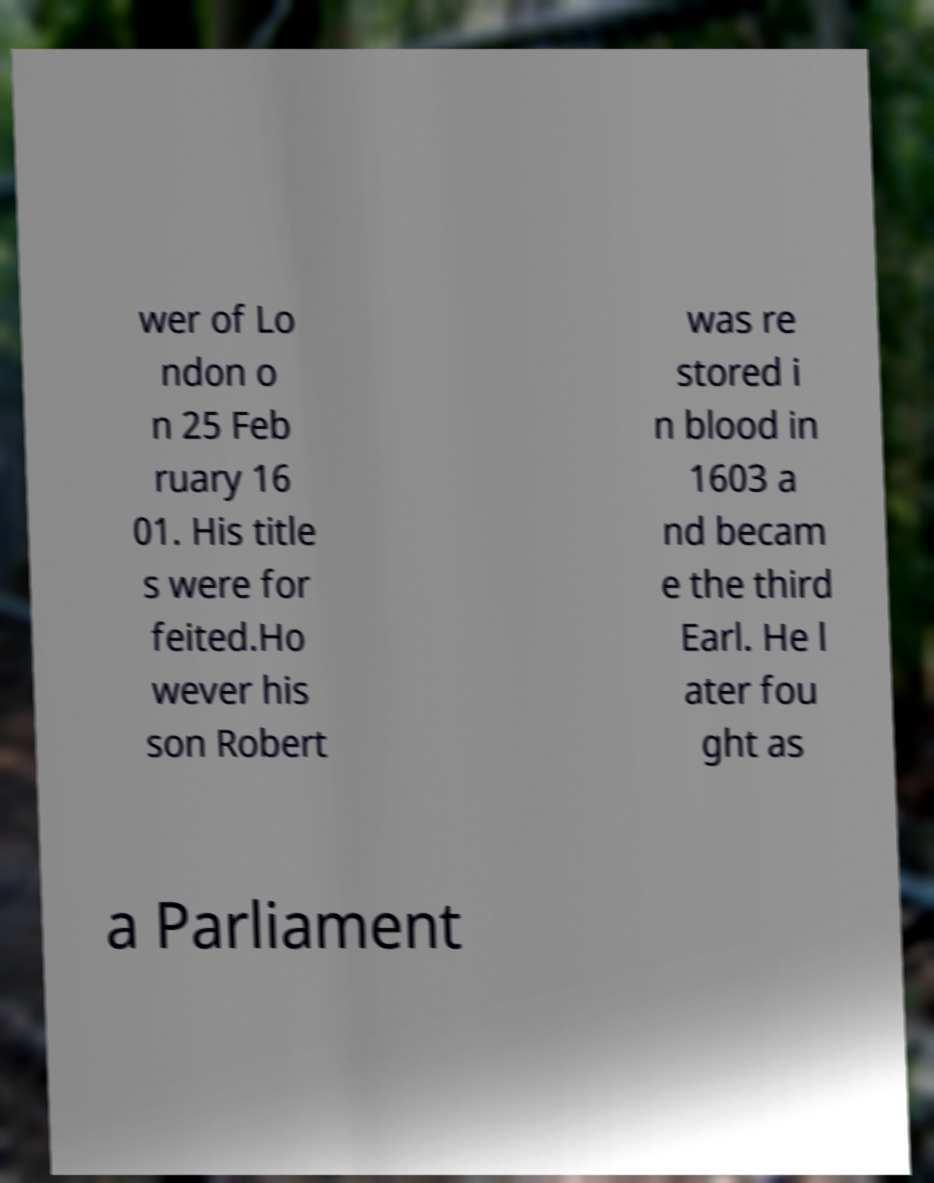Can you accurately transcribe the text from the provided image for me? wer of Lo ndon o n 25 Feb ruary 16 01. His title s were for feited.Ho wever his son Robert was re stored i n blood in 1603 a nd becam e the third Earl. He l ater fou ght as a Parliament 